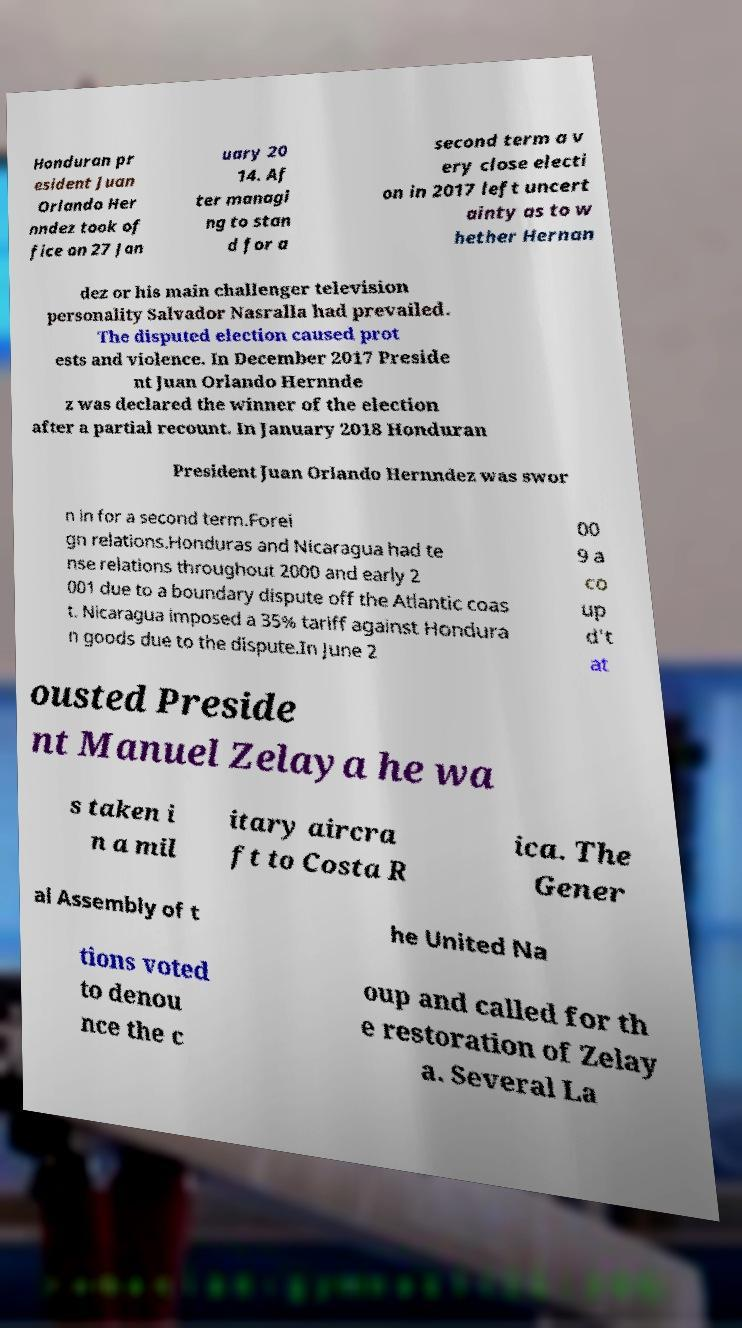Could you assist in decoding the text presented in this image and type it out clearly? Honduran pr esident Juan Orlando Her nndez took of fice on 27 Jan uary 20 14. Af ter managi ng to stan d for a second term a v ery close electi on in 2017 left uncert ainty as to w hether Hernan dez or his main challenger television personality Salvador Nasralla had prevailed. The disputed election caused prot ests and violence. In December 2017 Preside nt Juan Orlando Hernnde z was declared the winner of the election after a partial recount. In January 2018 Honduran President Juan Orlando Hernndez was swor n in for a second term.Forei gn relations.Honduras and Nicaragua had te nse relations throughout 2000 and early 2 001 due to a boundary dispute off the Atlantic coas t. Nicaragua imposed a 35% tariff against Hondura n goods due to the dispute.In June 2 00 9 a co up d't at ousted Preside nt Manuel Zelaya he wa s taken i n a mil itary aircra ft to Costa R ica. The Gener al Assembly of t he United Na tions voted to denou nce the c oup and called for th e restoration of Zelay a. Several La 